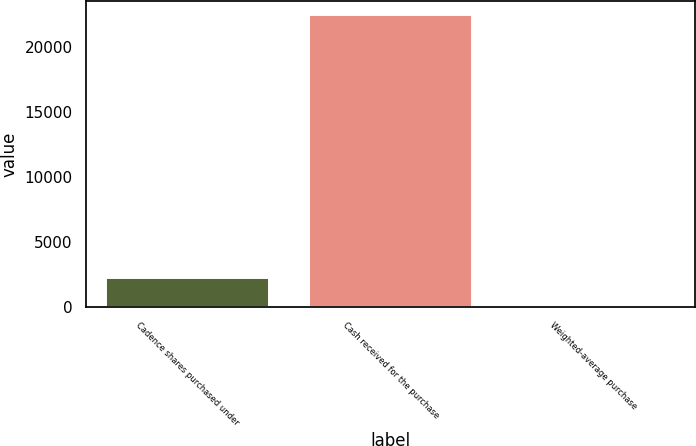Convert chart. <chart><loc_0><loc_0><loc_500><loc_500><bar_chart><fcel>Cadence shares purchased under<fcel>Cash received for the purchase<fcel>Weighted-average purchase<nl><fcel>2258.2<fcel>22449<fcel>14.78<nl></chart> 